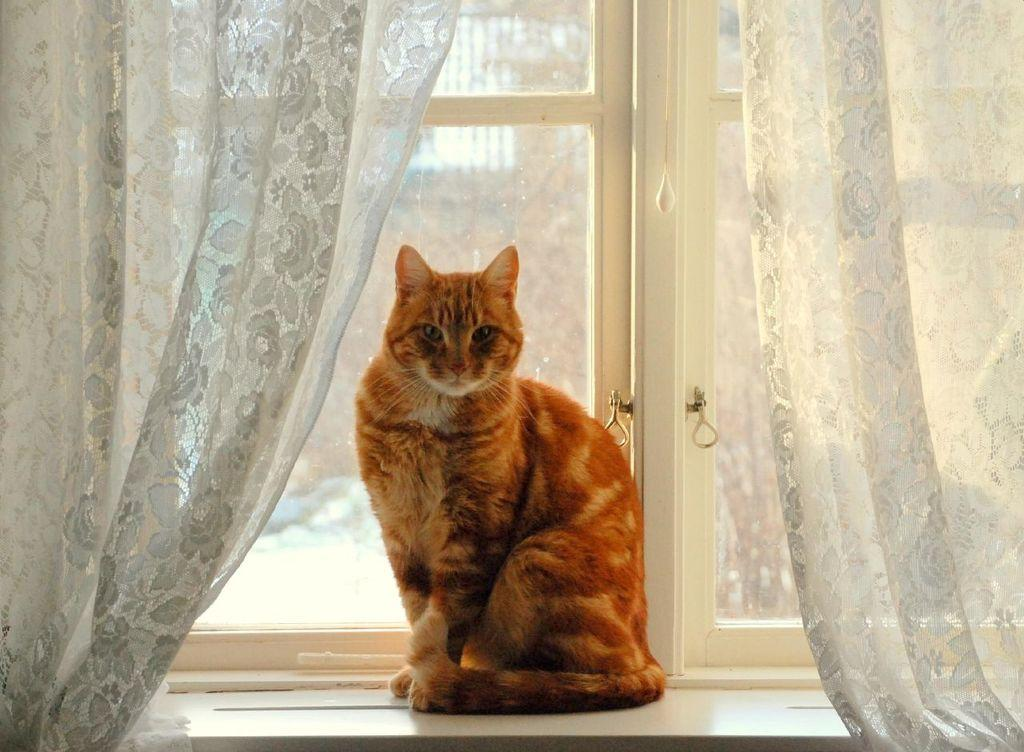What type of animal can be seen in the image? There is a cat in the image. What is the primary feature of the cat's environment? There is a glass window in the image. What type of window treatment is present in the image? There are curtains in the image. What can be seen through the glass window? A building is visible through the window glass. How many screws are visible on the cat's body in the image? There are no screws visible on the cat's body in the image. What is the mother of the cat doing in the image? There is no indication of the cat's mother in the image. 